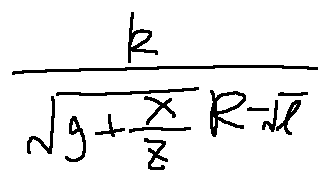<formula> <loc_0><loc_0><loc_500><loc_500>\frac { k } { \sqrt { g + \frac { X } { z } } ^ { R - \sqrt { l } } }</formula> 